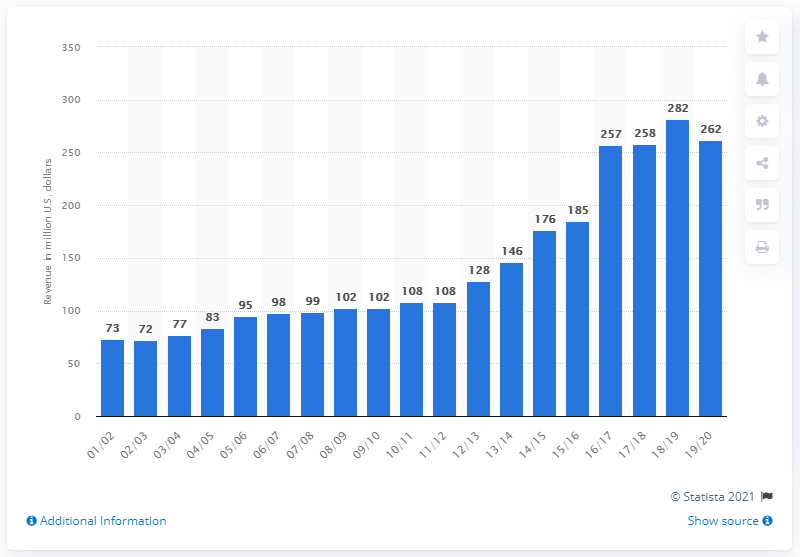Point out several critical features in this image. The estimated revenue of the NBA franchise in the 2019/2020 fiscal year was approximately 262 million dollars. 